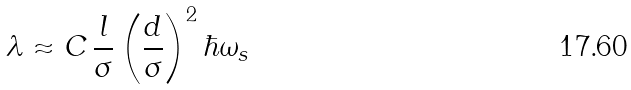<formula> <loc_0><loc_0><loc_500><loc_500>\lambda \approx C \, \frac { l } { \sigma } \left ( \frac { d } { \sigma } \right ) ^ { 2 } \hbar { \omega } _ { s }</formula> 